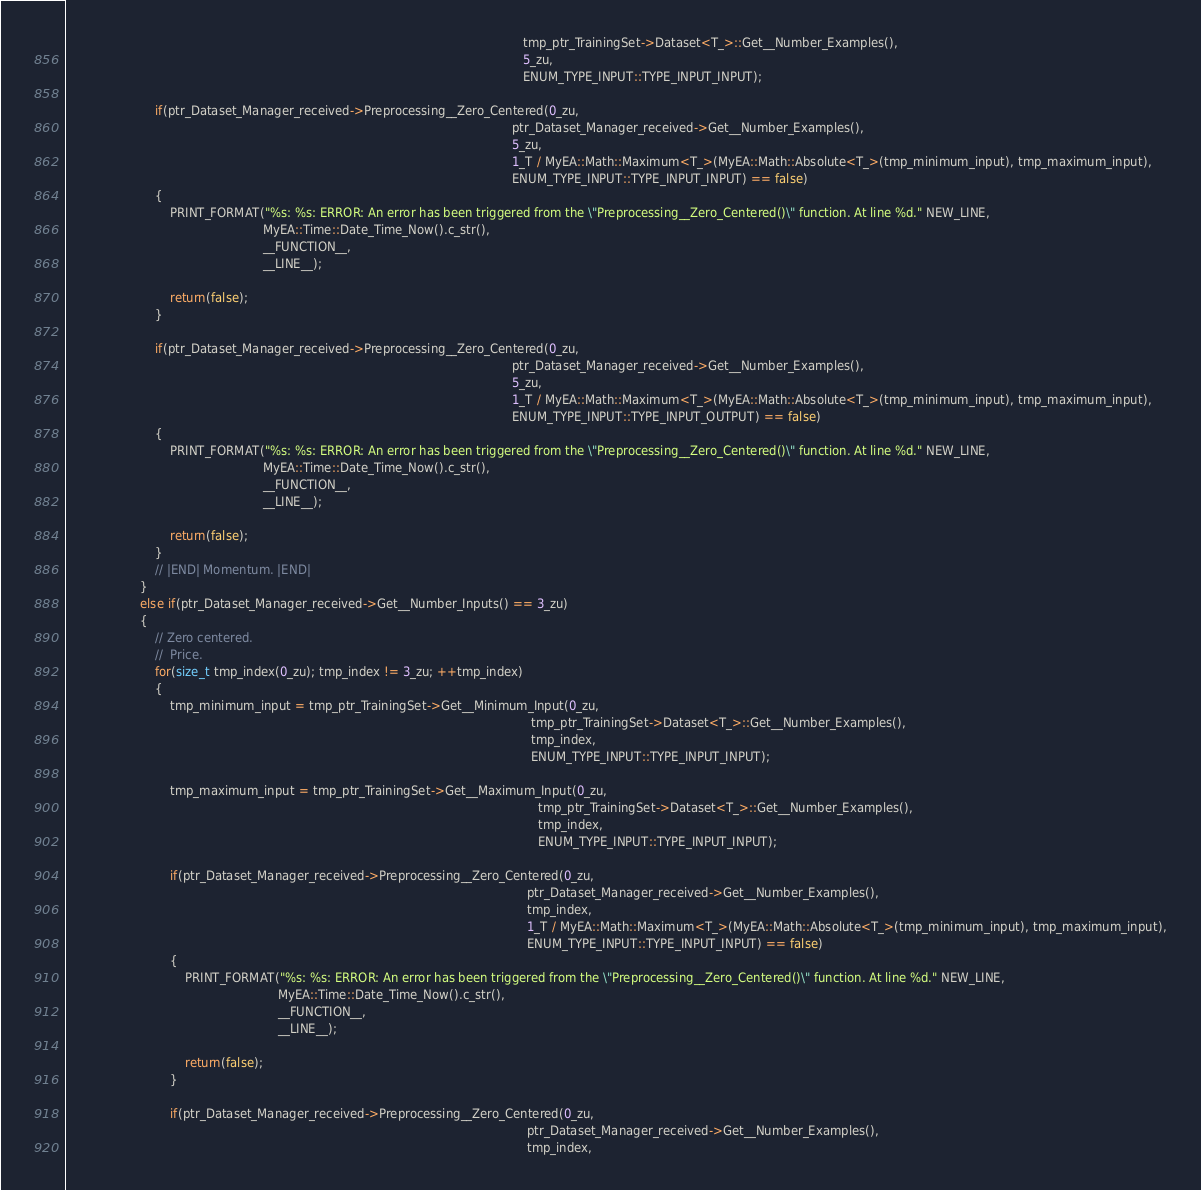<code> <loc_0><loc_0><loc_500><loc_500><_C++_>                                                                                                                           tmp_ptr_TrainingSet->Dataset<T_>::Get__Number_Examples(),
                                                                                                                           5_zu,
                                                                                                                           ENUM_TYPE_INPUT::TYPE_INPUT_INPUT);

                        if(ptr_Dataset_Manager_received->Preprocessing__Zero_Centered(0_zu,
                                                                                                                        ptr_Dataset_Manager_received->Get__Number_Examples(),
                                                                                                                        5_zu,
                                                                                                                        1_T / MyEA::Math::Maximum<T_>(MyEA::Math::Absolute<T_>(tmp_minimum_input), tmp_maximum_input),
                                                                                                                        ENUM_TYPE_INPUT::TYPE_INPUT_INPUT) == false)
                        {
                            PRINT_FORMAT("%s: %s: ERROR: An error has been triggered from the \"Preprocessing__Zero_Centered()\" function. At line %d." NEW_LINE,
                                                     MyEA::Time::Date_Time_Now().c_str(),
                                                     __FUNCTION__,
                                                     __LINE__);

                            return(false);
                        }

                        if(ptr_Dataset_Manager_received->Preprocessing__Zero_Centered(0_zu,
                                                                                                                        ptr_Dataset_Manager_received->Get__Number_Examples(),
                                                                                                                        5_zu,
                                                                                                                        1_T / MyEA::Math::Maximum<T_>(MyEA::Math::Absolute<T_>(tmp_minimum_input), tmp_maximum_input),
                                                                                                                        ENUM_TYPE_INPUT::TYPE_INPUT_OUTPUT) == false)
                        {
                            PRINT_FORMAT("%s: %s: ERROR: An error has been triggered from the \"Preprocessing__Zero_Centered()\" function. At line %d." NEW_LINE,
                                                     MyEA::Time::Date_Time_Now().c_str(),
                                                     __FUNCTION__,
                                                     __LINE__);

                            return(false);
                        }
                        // |END| Momentum. |END|
                    }
                    else if(ptr_Dataset_Manager_received->Get__Number_Inputs() == 3_zu)
                    {
                        // Zero centered.
                        //  Price.
                        for(size_t tmp_index(0_zu); tmp_index != 3_zu; ++tmp_index)
                        {
                            tmp_minimum_input = tmp_ptr_TrainingSet->Get__Minimum_Input(0_zu,
                                                                                                                             tmp_ptr_TrainingSet->Dataset<T_>::Get__Number_Examples(),
                                                                                                                             tmp_index,
                                                                                                                             ENUM_TYPE_INPUT::TYPE_INPUT_INPUT);
                        
                            tmp_maximum_input = tmp_ptr_TrainingSet->Get__Maximum_Input(0_zu,
                                                                                                                               tmp_ptr_TrainingSet->Dataset<T_>::Get__Number_Examples(),
                                                                                                                               tmp_index,
                                                                                                                               ENUM_TYPE_INPUT::TYPE_INPUT_INPUT);

                            if(ptr_Dataset_Manager_received->Preprocessing__Zero_Centered(0_zu,
                                                                                                                            ptr_Dataset_Manager_received->Get__Number_Examples(),
                                                                                                                            tmp_index,
                                                                                                                            1_T / MyEA::Math::Maximum<T_>(MyEA::Math::Absolute<T_>(tmp_minimum_input), tmp_maximum_input),
                                                                                                                            ENUM_TYPE_INPUT::TYPE_INPUT_INPUT) == false)
                            {
                                PRINT_FORMAT("%s: %s: ERROR: An error has been triggered from the \"Preprocessing__Zero_Centered()\" function. At line %d." NEW_LINE,
                                                         MyEA::Time::Date_Time_Now().c_str(),
                                                         __FUNCTION__,
                                                         __LINE__);

                                return(false);
                            }

                            if(ptr_Dataset_Manager_received->Preprocessing__Zero_Centered(0_zu,
                                                                                                                            ptr_Dataset_Manager_received->Get__Number_Examples(),
                                                                                                                            tmp_index,</code> 